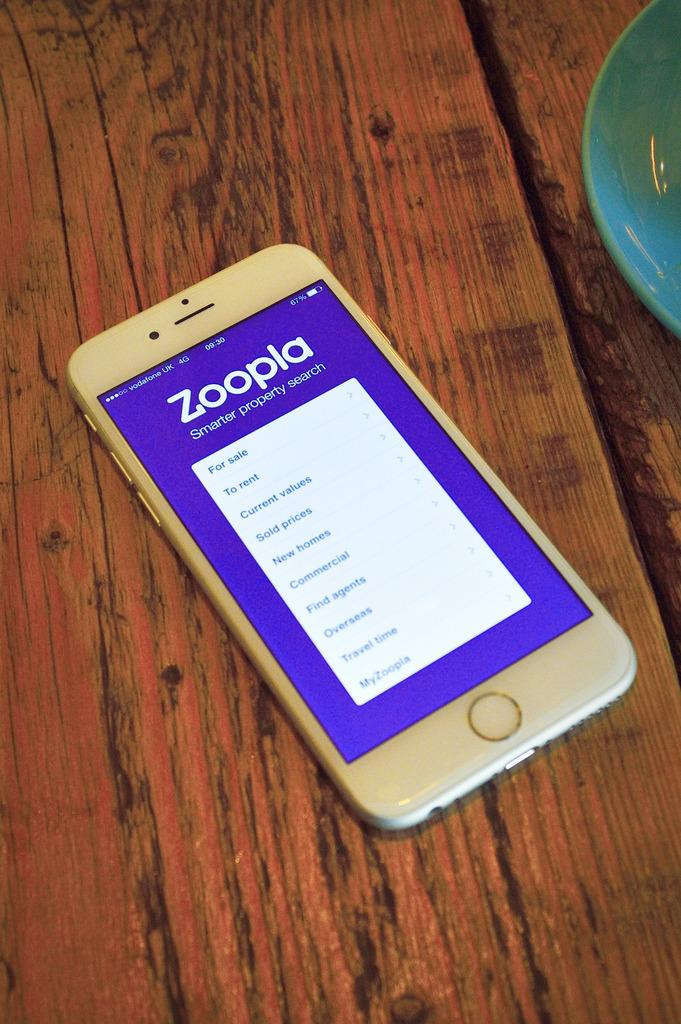<image>
Render a clear and concise summary of the photo. A white cell phone open to  Zoopla, a property search application. 